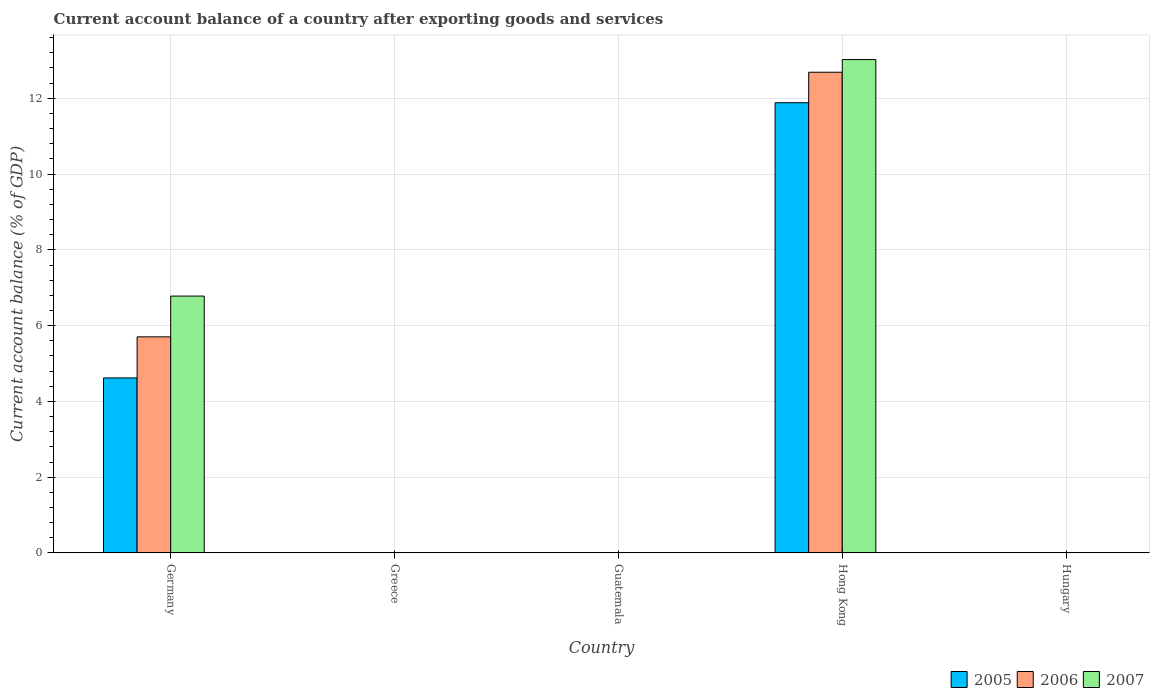Are the number of bars per tick equal to the number of legend labels?
Your answer should be compact. No. Are the number of bars on each tick of the X-axis equal?
Offer a very short reply. No. How many bars are there on the 5th tick from the left?
Your answer should be compact. 0. What is the account balance in 2006 in Germany?
Your answer should be very brief. 5.7. Across all countries, what is the maximum account balance in 2007?
Keep it short and to the point. 13.02. In which country was the account balance in 2007 maximum?
Your answer should be compact. Hong Kong. What is the total account balance in 2005 in the graph?
Your answer should be compact. 16.5. What is the difference between the account balance in 2007 in Germany and that in Hong Kong?
Your answer should be compact. -6.24. What is the difference between the account balance in 2006 in Germany and the account balance in 2007 in Hong Kong?
Give a very brief answer. -7.32. What is the average account balance in 2005 per country?
Keep it short and to the point. 3.3. What is the difference between the account balance of/in 2005 and account balance of/in 2006 in Hong Kong?
Provide a short and direct response. -0.81. Is the difference between the account balance in 2005 in Germany and Hong Kong greater than the difference between the account balance in 2006 in Germany and Hong Kong?
Make the answer very short. No. What is the difference between the highest and the lowest account balance in 2005?
Provide a short and direct response. 11.88. Is it the case that in every country, the sum of the account balance in 2006 and account balance in 2005 is greater than the account balance in 2007?
Offer a very short reply. No. How many bars are there?
Ensure brevity in your answer.  6. Are all the bars in the graph horizontal?
Your response must be concise. No. How many countries are there in the graph?
Provide a succinct answer. 5. Does the graph contain any zero values?
Provide a succinct answer. Yes. How many legend labels are there?
Ensure brevity in your answer.  3. What is the title of the graph?
Keep it short and to the point. Current account balance of a country after exporting goods and services. What is the label or title of the X-axis?
Keep it short and to the point. Country. What is the label or title of the Y-axis?
Offer a very short reply. Current account balance (% of GDP). What is the Current account balance (% of GDP) of 2005 in Germany?
Make the answer very short. 4.62. What is the Current account balance (% of GDP) of 2006 in Germany?
Your answer should be very brief. 5.7. What is the Current account balance (% of GDP) in 2007 in Germany?
Provide a short and direct response. 6.78. What is the Current account balance (% of GDP) in 2005 in Greece?
Your answer should be compact. 0. What is the Current account balance (% of GDP) in 2006 in Greece?
Keep it short and to the point. 0. What is the Current account balance (% of GDP) of 2007 in Greece?
Your answer should be very brief. 0. What is the Current account balance (% of GDP) in 2007 in Guatemala?
Ensure brevity in your answer.  0. What is the Current account balance (% of GDP) in 2005 in Hong Kong?
Ensure brevity in your answer.  11.88. What is the Current account balance (% of GDP) in 2006 in Hong Kong?
Provide a succinct answer. 12.69. What is the Current account balance (% of GDP) of 2007 in Hong Kong?
Offer a terse response. 13.02. What is the Current account balance (% of GDP) of 2006 in Hungary?
Ensure brevity in your answer.  0. Across all countries, what is the maximum Current account balance (% of GDP) of 2005?
Offer a very short reply. 11.88. Across all countries, what is the maximum Current account balance (% of GDP) in 2006?
Offer a very short reply. 12.69. Across all countries, what is the maximum Current account balance (% of GDP) in 2007?
Provide a succinct answer. 13.02. Across all countries, what is the minimum Current account balance (% of GDP) of 2005?
Provide a short and direct response. 0. What is the total Current account balance (% of GDP) in 2005 in the graph?
Provide a short and direct response. 16.5. What is the total Current account balance (% of GDP) in 2006 in the graph?
Ensure brevity in your answer.  18.39. What is the total Current account balance (% of GDP) in 2007 in the graph?
Make the answer very short. 19.8. What is the difference between the Current account balance (% of GDP) of 2005 in Germany and that in Hong Kong?
Keep it short and to the point. -7.26. What is the difference between the Current account balance (% of GDP) of 2006 in Germany and that in Hong Kong?
Provide a succinct answer. -6.98. What is the difference between the Current account balance (% of GDP) in 2007 in Germany and that in Hong Kong?
Provide a succinct answer. -6.24. What is the difference between the Current account balance (% of GDP) in 2005 in Germany and the Current account balance (% of GDP) in 2006 in Hong Kong?
Your answer should be compact. -8.07. What is the difference between the Current account balance (% of GDP) of 2005 in Germany and the Current account balance (% of GDP) of 2007 in Hong Kong?
Offer a terse response. -8.4. What is the difference between the Current account balance (% of GDP) in 2006 in Germany and the Current account balance (% of GDP) in 2007 in Hong Kong?
Give a very brief answer. -7.32. What is the average Current account balance (% of GDP) in 2005 per country?
Offer a terse response. 3.3. What is the average Current account balance (% of GDP) of 2006 per country?
Offer a very short reply. 3.68. What is the average Current account balance (% of GDP) in 2007 per country?
Provide a succinct answer. 3.96. What is the difference between the Current account balance (% of GDP) in 2005 and Current account balance (% of GDP) in 2006 in Germany?
Provide a short and direct response. -1.08. What is the difference between the Current account balance (% of GDP) of 2005 and Current account balance (% of GDP) of 2007 in Germany?
Keep it short and to the point. -2.16. What is the difference between the Current account balance (% of GDP) in 2006 and Current account balance (% of GDP) in 2007 in Germany?
Offer a terse response. -1.08. What is the difference between the Current account balance (% of GDP) in 2005 and Current account balance (% of GDP) in 2006 in Hong Kong?
Provide a succinct answer. -0.81. What is the difference between the Current account balance (% of GDP) in 2005 and Current account balance (% of GDP) in 2007 in Hong Kong?
Your answer should be very brief. -1.14. What is the difference between the Current account balance (% of GDP) of 2006 and Current account balance (% of GDP) of 2007 in Hong Kong?
Your response must be concise. -0.33. What is the ratio of the Current account balance (% of GDP) of 2005 in Germany to that in Hong Kong?
Provide a succinct answer. 0.39. What is the ratio of the Current account balance (% of GDP) in 2006 in Germany to that in Hong Kong?
Your answer should be compact. 0.45. What is the ratio of the Current account balance (% of GDP) of 2007 in Germany to that in Hong Kong?
Your answer should be compact. 0.52. What is the difference between the highest and the lowest Current account balance (% of GDP) of 2005?
Your response must be concise. 11.88. What is the difference between the highest and the lowest Current account balance (% of GDP) of 2006?
Ensure brevity in your answer.  12.69. What is the difference between the highest and the lowest Current account balance (% of GDP) in 2007?
Keep it short and to the point. 13.02. 